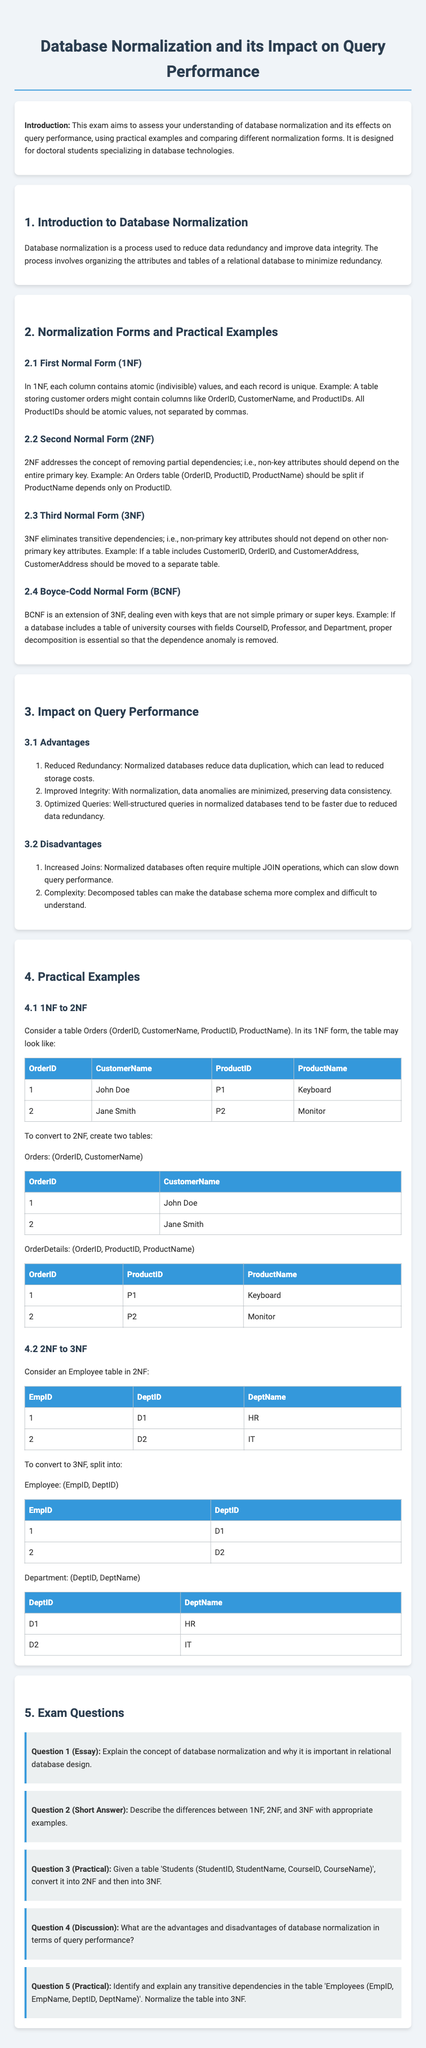What is database normalization? Database normalization is a process used to reduce data redundancy and improve data integrity.
Answer: Reducing data redundancy and improving data integrity What does 1NF require? 1NF requires each column to contain atomic values and each record to be unique.
Answer: Atomic values and unique records What is the main goal of 2NF? The main goal of 2NF is to remove partial dependencies on the primary key.
Answer: Remove partial dependencies What is an advantage of normalization? An advantage of normalization includes reduced redundancy, which can lead to reduced storage costs.
Answer: Reduced redundancy What is one disadvantage of normalization? One disadvantage of normalization is that it can increase the number of joins needed in queries.
Answer: Increased joins What does BCNF extend? BCNF is an extension of 3NF.
Answer: 3NF Which table is created in 2NF from Orders? In 2NF, the Orders table is split into Orders and OrderDetails.
Answer: Orders and OrderDetails What is the example given for 3NF? The example given for 3NF involves splitting the Employee table into Employee and Department tables.
Answer: Employee and Department tables What is a requirement of 3NF? A requirement of 3NF is that non-primary key attributes should not depend on other non-primary key attributes.
Answer: No transitive dependencies What does a table in 1NF contain? A table in 1NF contains atomic values, and all ProductIDs should be atomic values.
Answer: Atomic values 